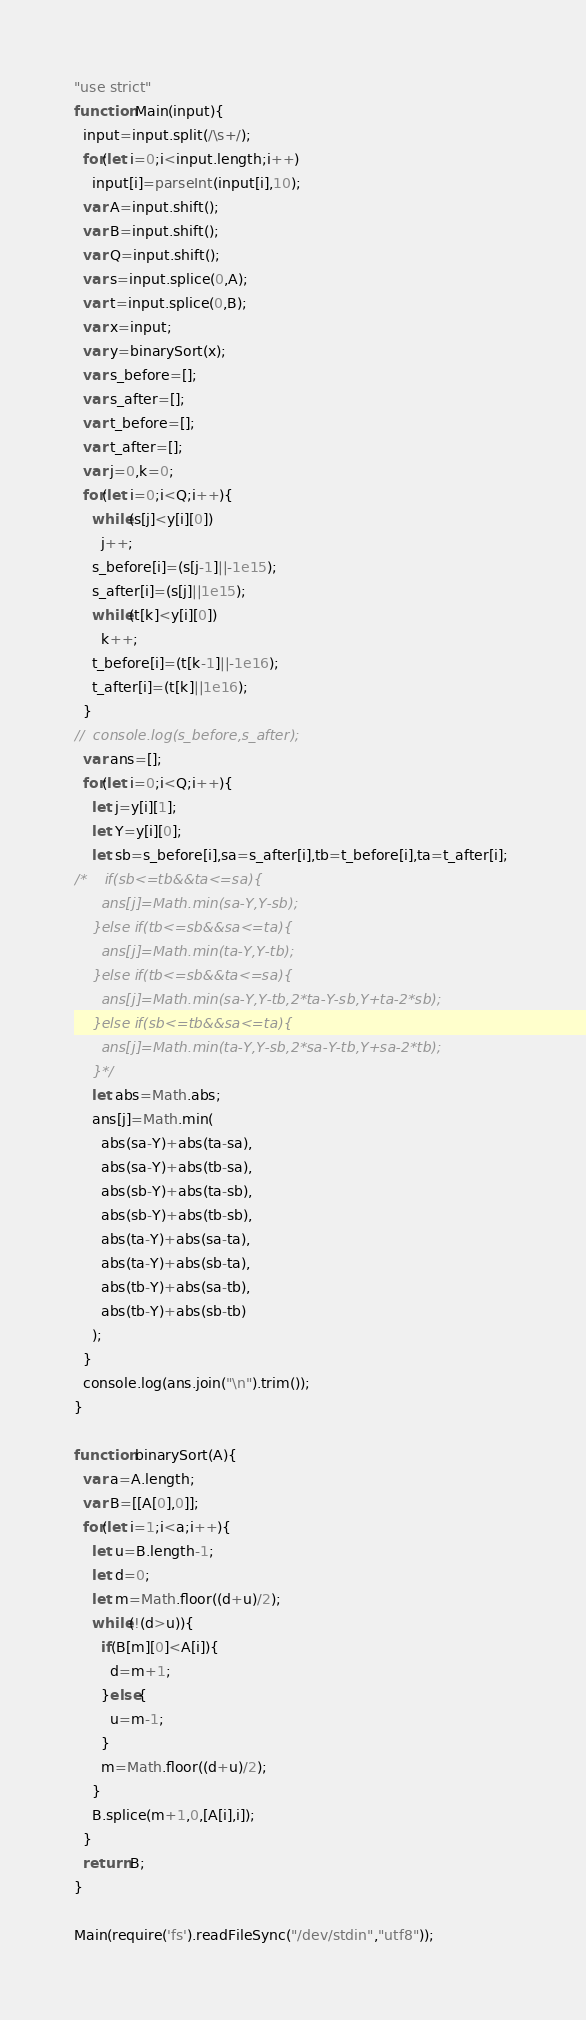Convert code to text. <code><loc_0><loc_0><loc_500><loc_500><_JavaScript_>"use strict"
function Main(input){
  input=input.split(/\s+/);
  for(let i=0;i<input.length;i++)
    input[i]=parseInt(input[i],10);
  var A=input.shift();
  var B=input.shift();
  var Q=input.shift();
  var s=input.splice(0,A);
  var t=input.splice(0,B);
  var x=input;
  var y=binarySort(x);
  var s_before=[];
  var s_after=[];
  var t_before=[];
  var t_after=[];
  var j=0,k=0;
  for(let i=0;i<Q;i++){
    while(s[j]<y[i][0])
      j++;
    s_before[i]=(s[j-1]||-1e15);
    s_after[i]=(s[j]||1e15);
    while(t[k]<y[i][0])
      k++;
    t_before[i]=(t[k-1]||-1e16);
    t_after[i]=(t[k]||1e16);
  }
//  console.log(s_before,s_after);
  var ans=[];
  for(let i=0;i<Q;i++){
    let j=y[i][1];
    let Y=y[i][0];
    let sb=s_before[i],sa=s_after[i],tb=t_before[i],ta=t_after[i]; 
/*    if(sb<=tb&&ta<=sa){
      ans[j]=Math.min(sa-Y,Y-sb);
    }else if(tb<=sb&&sa<=ta){
      ans[j]=Math.min(ta-Y,Y-tb);
    }else if(tb<=sb&&ta<=sa){
      ans[j]=Math.min(sa-Y,Y-tb,2*ta-Y-sb,Y+ta-2*sb);
    }else if(sb<=tb&&sa<=ta){
      ans[j]=Math.min(ta-Y,Y-sb,2*sa-Y-tb,Y+sa-2*tb);
    }*/
    let abs=Math.abs;
    ans[j]=Math.min(
      abs(sa-Y)+abs(ta-sa),
      abs(sa-Y)+abs(tb-sa),
      abs(sb-Y)+abs(ta-sb),
      abs(sb-Y)+abs(tb-sb),
      abs(ta-Y)+abs(sa-ta),
      abs(ta-Y)+abs(sb-ta),
      abs(tb-Y)+abs(sa-tb),
      abs(tb-Y)+abs(sb-tb)
    );
  }
  console.log(ans.join("\n").trim());
}

function binarySort(A){
  var a=A.length;
  var B=[[A[0],0]];
  for(let i=1;i<a;i++){
    let u=B.length-1;
    let d=0;
    let m=Math.floor((d+u)/2);
    while(!(d>u)){
      if(B[m][0]<A[i]){
        d=m+1;
      }else{
        u=m-1;
      }
      m=Math.floor((d+u)/2);
    }
    B.splice(m+1,0,[A[i],i]);
  }
  return B;
}

Main(require('fs').readFileSync("/dev/stdin","utf8"));</code> 